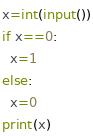Convert code to text. <code><loc_0><loc_0><loc_500><loc_500><_Python_>x=int(input())
if x==0:
  x=1
else:
  x=0
print(x)</code> 